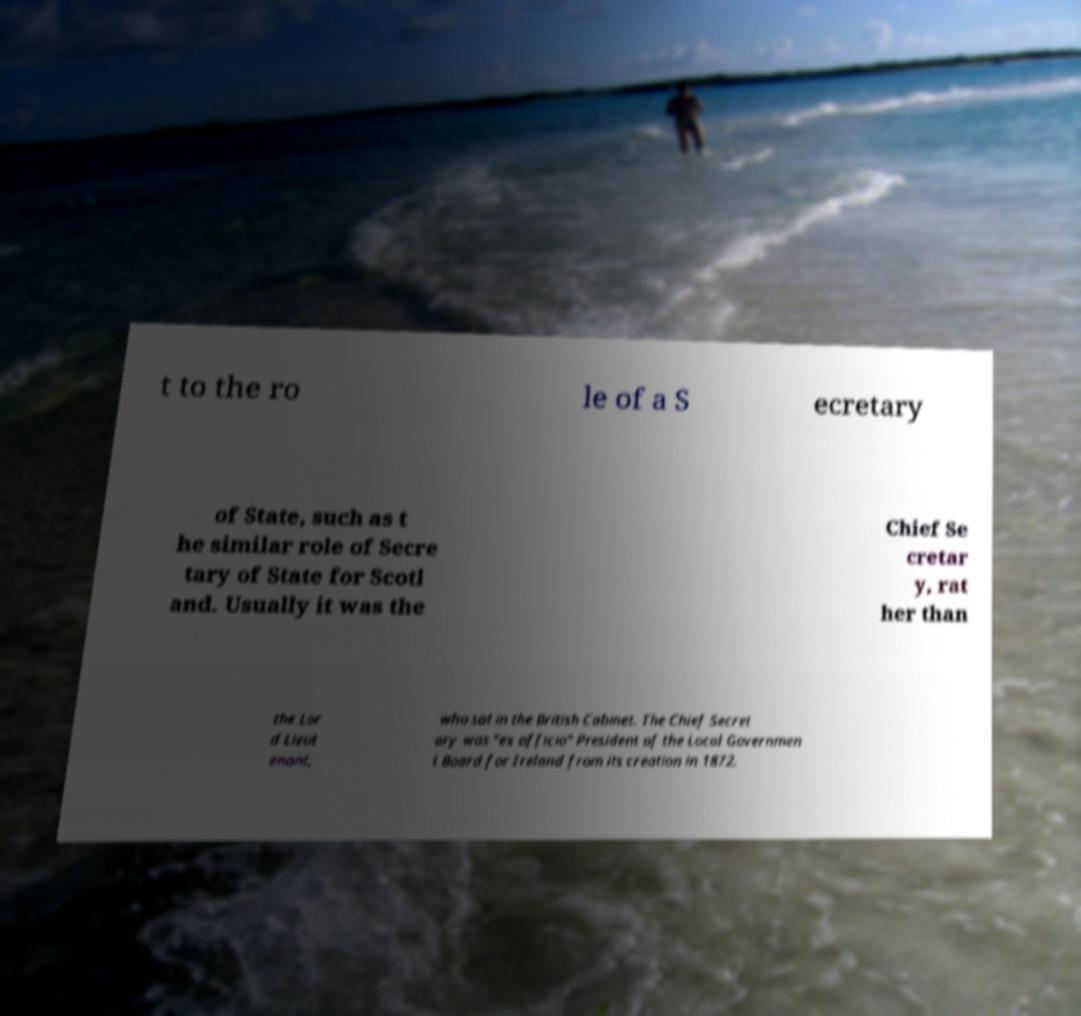Can you accurately transcribe the text from the provided image for me? t to the ro le of a S ecretary of State, such as t he similar role of Secre tary of State for Scotl and. Usually it was the Chief Se cretar y, rat her than the Lor d Lieut enant, who sat in the British Cabinet. The Chief Secret ary was "ex officio" President of the Local Governmen t Board for Ireland from its creation in 1872. 